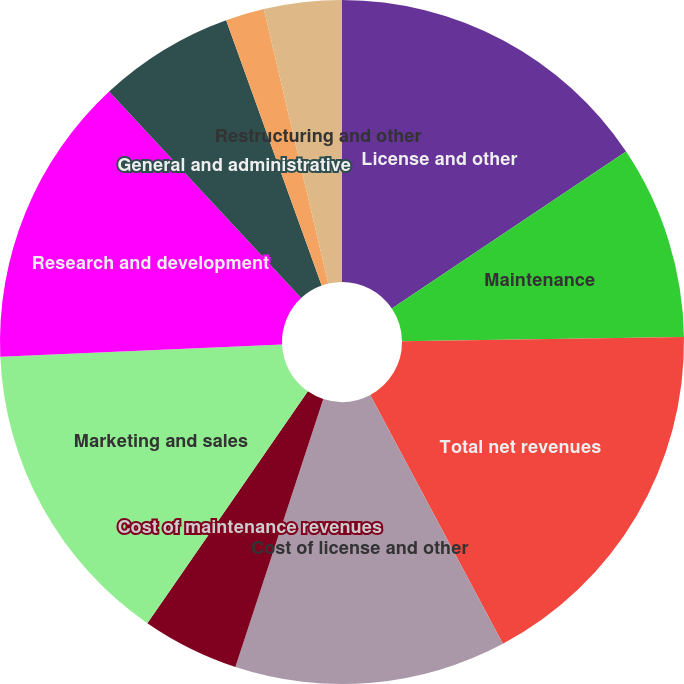<chart> <loc_0><loc_0><loc_500><loc_500><pie_chart><fcel>License and other<fcel>Maintenance<fcel>Total net revenues<fcel>Cost of license and other<fcel>Cost of maintenance revenues<fcel>Marketing and sales<fcel>Research and development<fcel>General and administrative<fcel>Amortization of goodwill and<fcel>Restructuring and other<nl><fcel>15.6%<fcel>9.17%<fcel>17.43%<fcel>12.84%<fcel>4.59%<fcel>14.68%<fcel>13.76%<fcel>6.42%<fcel>1.83%<fcel>3.67%<nl></chart> 